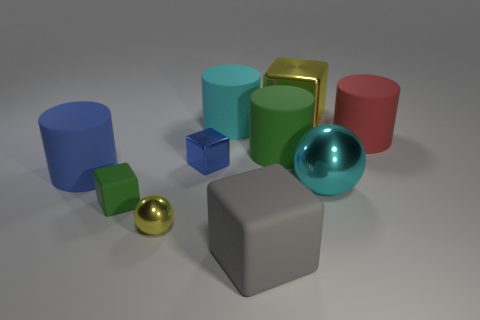Subtract all spheres. How many objects are left? 8 Subtract 0 red blocks. How many objects are left? 10 Subtract all big yellow rubber blocks. Subtract all big gray things. How many objects are left? 9 Add 4 large blue cylinders. How many large blue cylinders are left? 5 Add 8 cyan matte cylinders. How many cyan matte cylinders exist? 9 